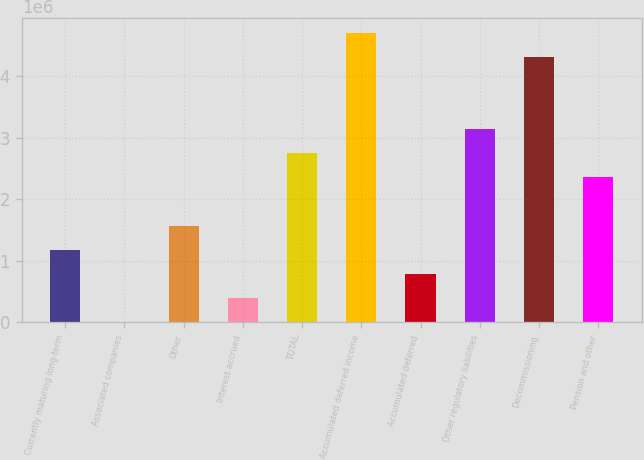Convert chart. <chart><loc_0><loc_0><loc_500><loc_500><bar_chart><fcel>Currently maturing long-term<fcel>Associated companies<fcel>Other<fcel>Interest accrued<fcel>TOTAL<fcel>Accumulated deferred income<fcel>Accumulated deferred<fcel>Other regulatory liabilities<fcel>Decommissioning<fcel>Pension and other<nl><fcel>1.1824e+06<fcel>5843<fcel>1.57459e+06<fcel>398030<fcel>2.75115e+06<fcel>4.71209e+06<fcel>790217<fcel>3.14334e+06<fcel>4.3199e+06<fcel>2.35896e+06<nl></chart> 